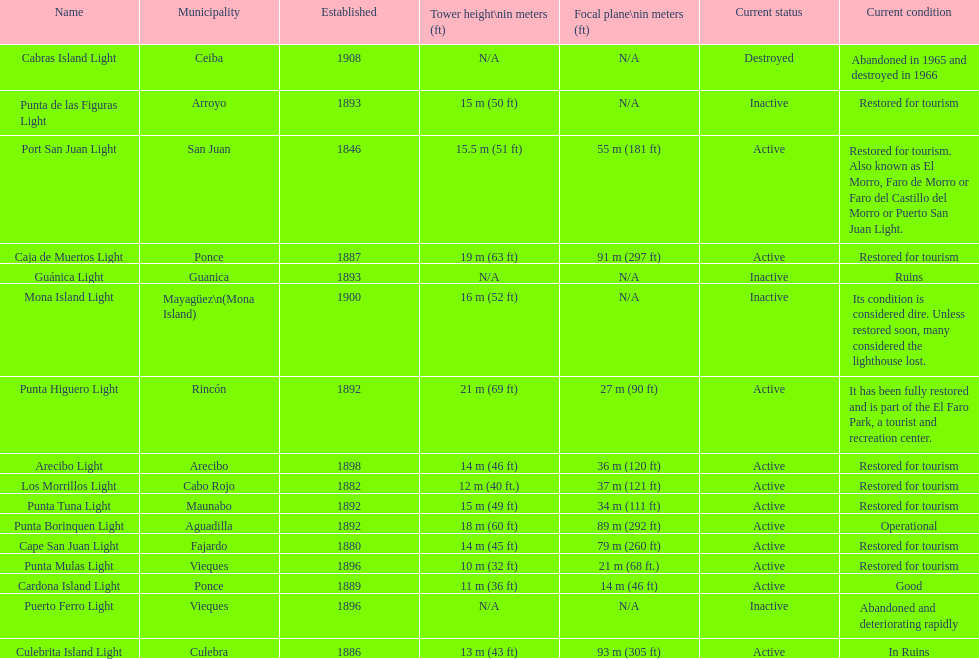Which municipality was the first to be established? San Juan. 